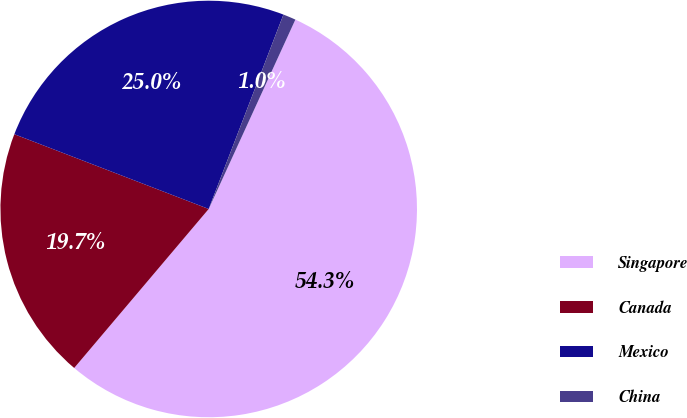<chart> <loc_0><loc_0><loc_500><loc_500><pie_chart><fcel>Singapore<fcel>Canada<fcel>Mexico<fcel>China<nl><fcel>54.35%<fcel>19.67%<fcel>25.0%<fcel>0.99%<nl></chart> 